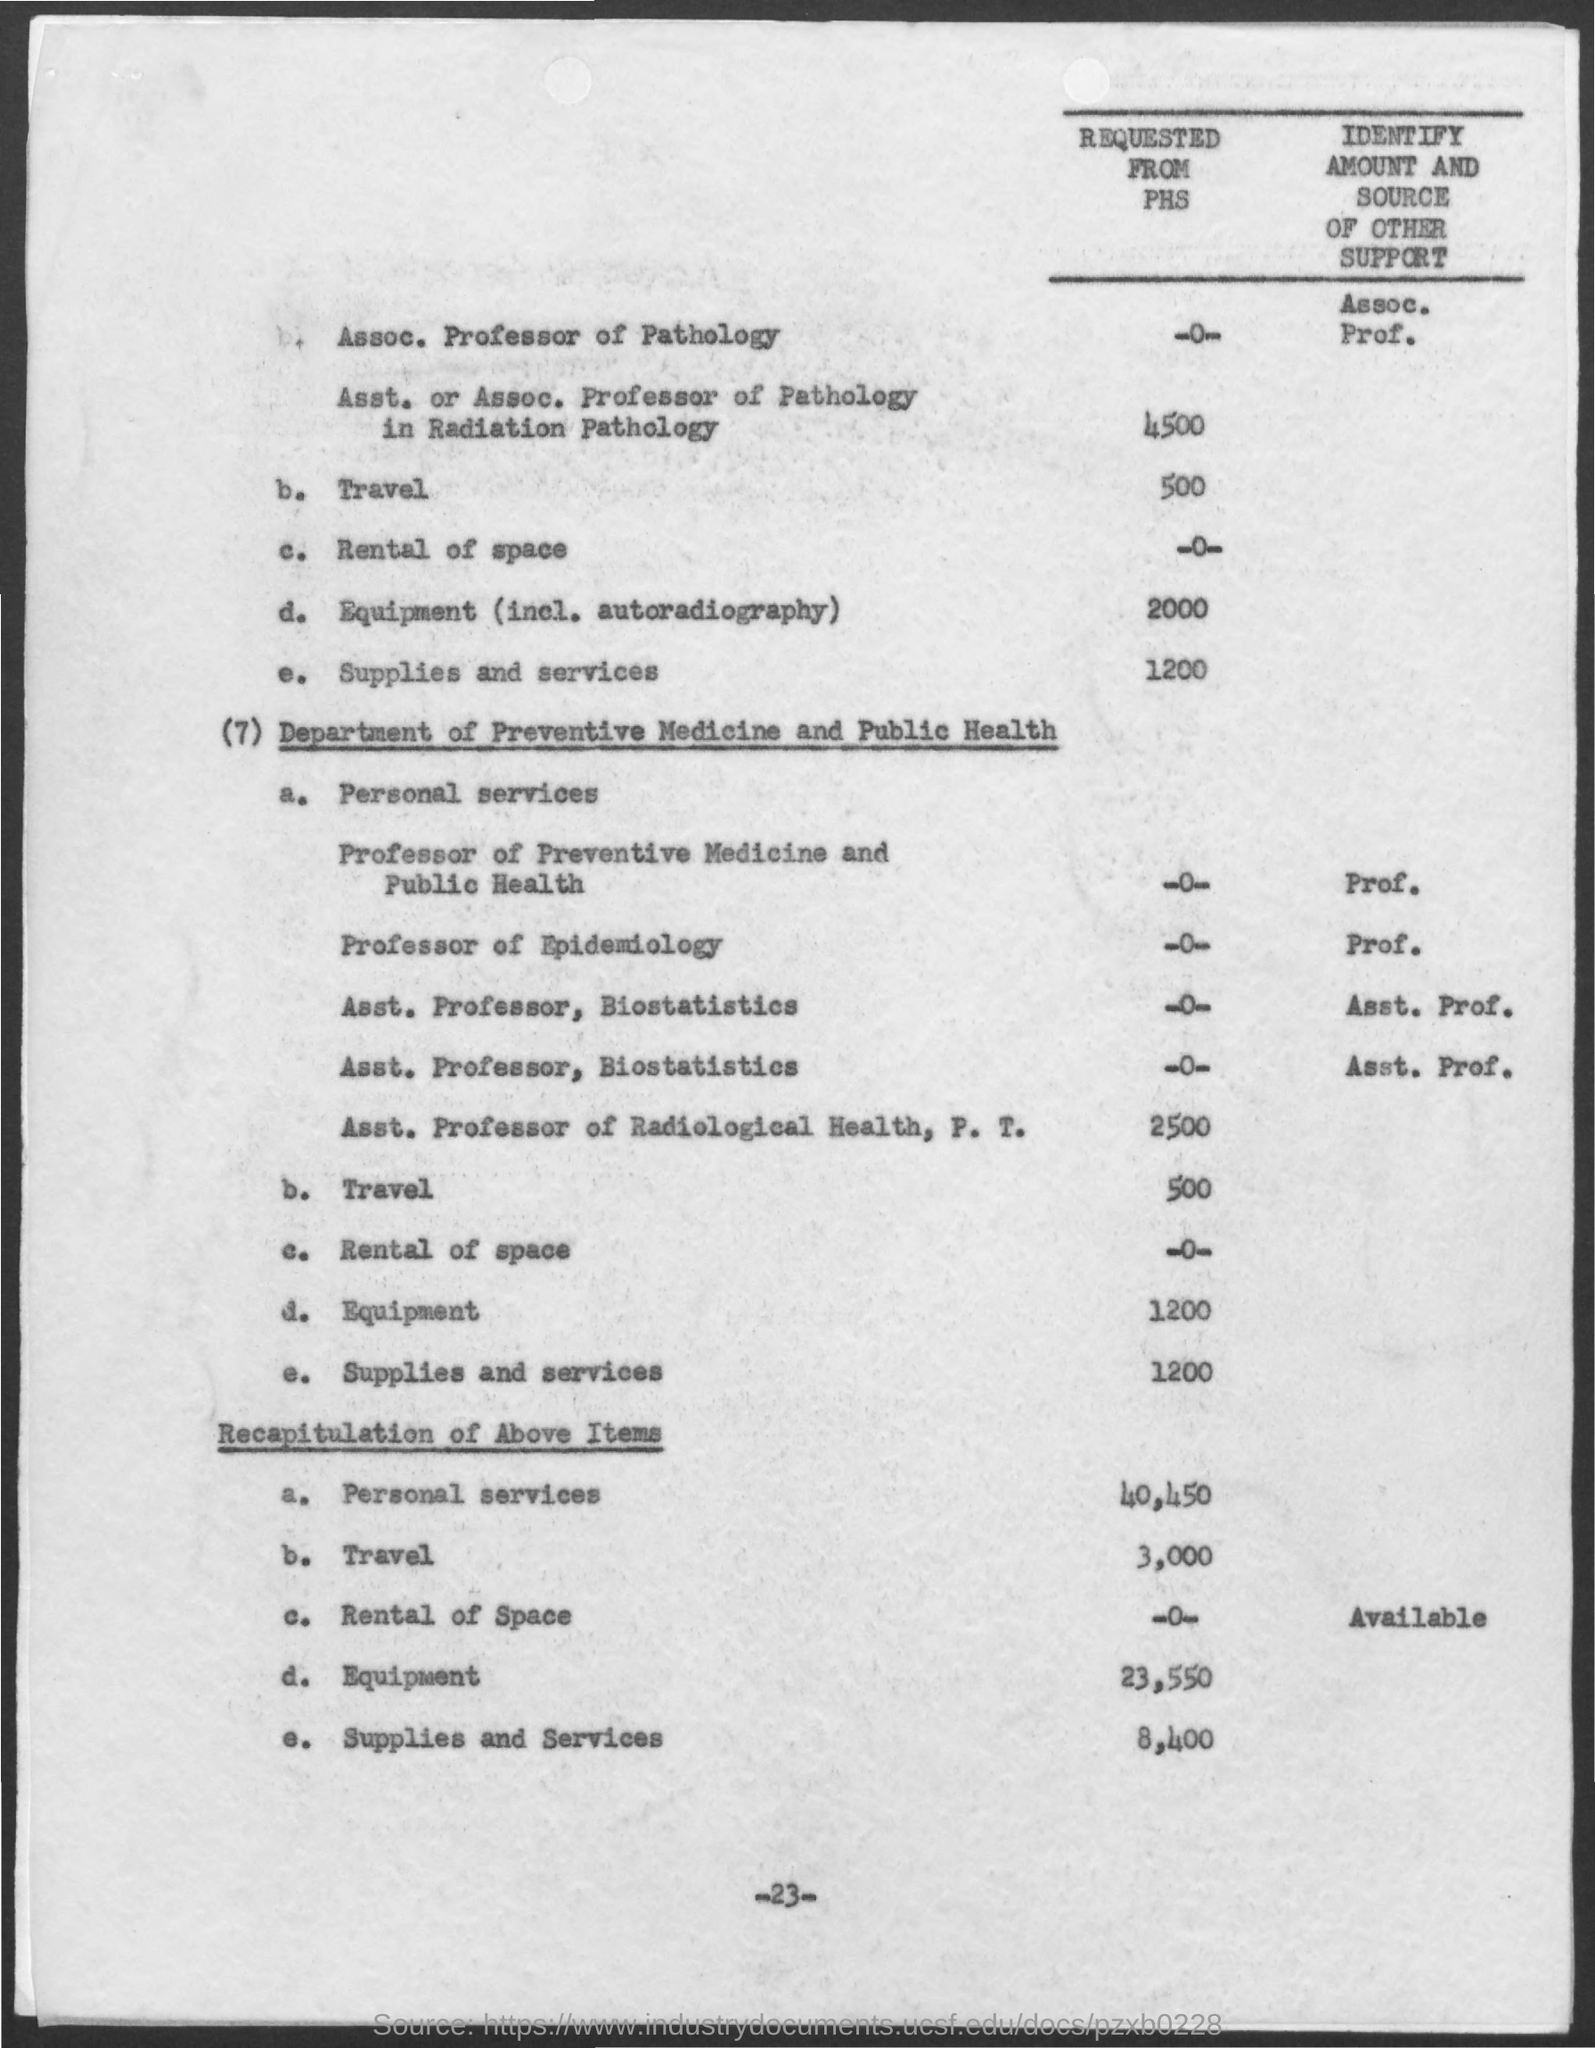What is the Page Number?
Ensure brevity in your answer.  23. 